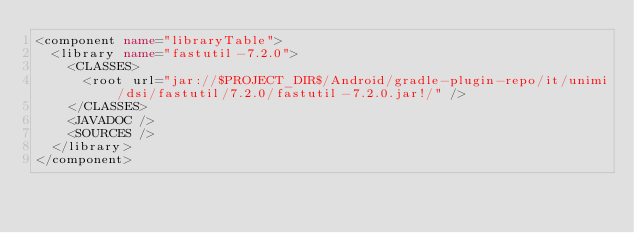Convert code to text. <code><loc_0><loc_0><loc_500><loc_500><_XML_><component name="libraryTable">
  <library name="fastutil-7.2.0">
    <CLASSES>
      <root url="jar://$PROJECT_DIR$/Android/gradle-plugin-repo/it/unimi/dsi/fastutil/7.2.0/fastutil-7.2.0.jar!/" />
    </CLASSES>
    <JAVADOC />
    <SOURCES />
  </library>
</component></code> 